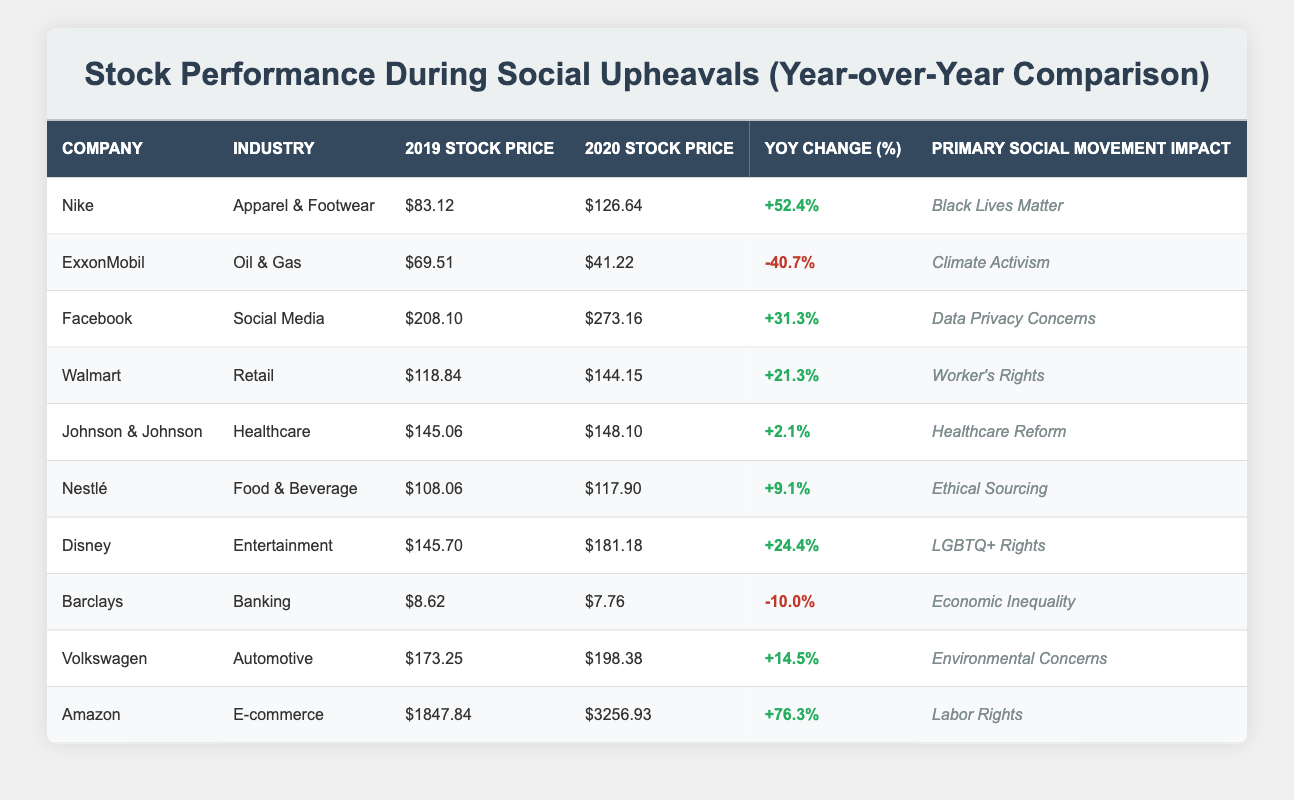What was the YoY change percentage for Nike in 2020? Referring to the table, Nike's YoY Change is listed as +52.4% for the year 2020.
Answer: +52.4% Which company had the largest YoY stock price increase? By scanning the YoY Change column, Amazon has the highest increase at +76.3%.
Answer: Amazon Did Johnson & Johnson's stock price increase or decrease from 2019 to 2020? Checking the YoY Change for Johnson & Johnson, it shows +2.1%, indicating that the stock price increased.
Answer: Yes What was the average YoY change percentage for the apparel and footwear industry? The YoY changes for Nike in the apparel industry is +52.4%. Thus, the average for apparel and footwear is simply 52.4% as there is only one representative company in the table.
Answer: 52.4% Which companies experienced a negative change in stock price, and what were their YoY changes? Looking through the table, ExxonMobil's YoY change is -40.7% and Barclays's is -10.0%. Both companies experienced a negative change.
Answer: ExxonMobil: -40.7%, Barclays: -10.0% What is the total YoY percentage change for companies involved in social movements related to workers' rights? The only company linked to workers' rights is Walmart with a YoY change of +21.3%. As there are no other companies in this category, the total is simply Walmart's YoY change.
Answer: +21.3% Which industry had the best stock performance in terms of YoY change? Comparing all industries, the highest YoY change is from the e-commerce industry, represented by Amazon with +76.3%.
Answer: E-commerce Is it true that all companies in the food and beverage sector had positive stock price changes? The only company listed in the food and beverage sector is Nestlé, which had a YoY change of +9.1%, confirming the statement as true.
Answer: Yes What is the difference in stock price change between the best-performing company (Amazon) and the worst-performing company (ExxonMobil)? Amazon's YoY change is +76.3% and ExxonMobil's is -40.7%. The difference is calculated as 76.3% - (-40.7%) = 117%.
Answer: 117% 